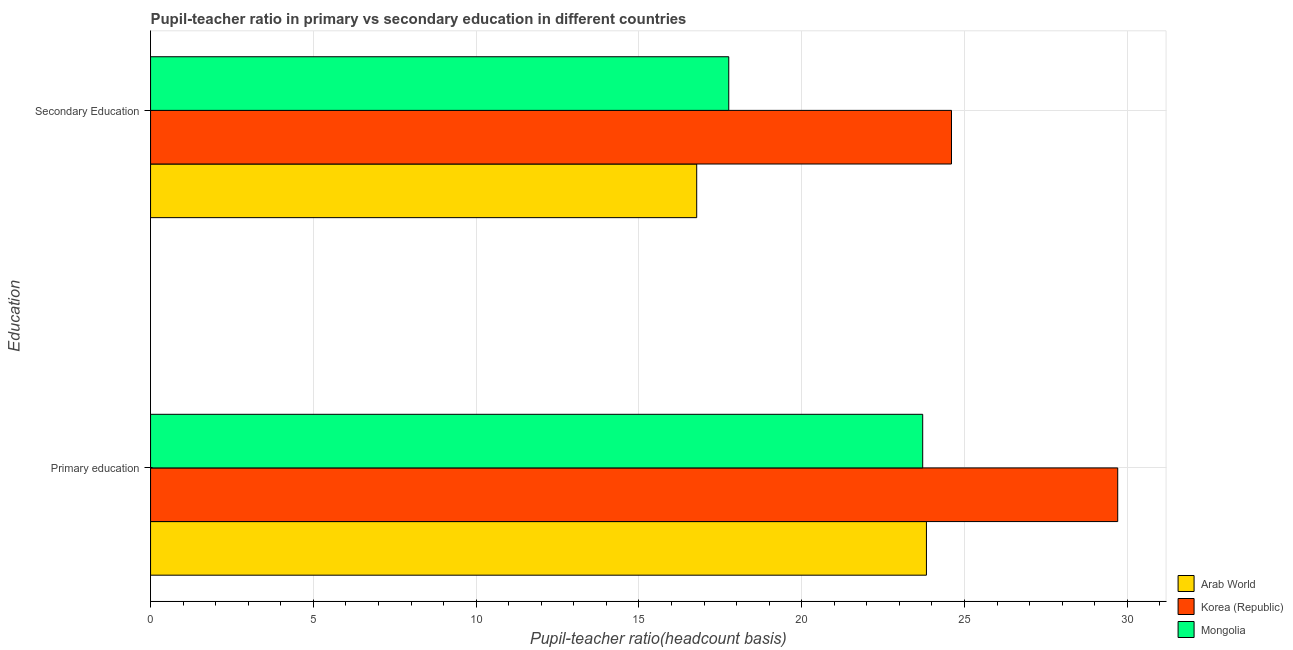How many groups of bars are there?
Provide a short and direct response. 2. Are the number of bars per tick equal to the number of legend labels?
Offer a terse response. Yes. Are the number of bars on each tick of the Y-axis equal?
Offer a terse response. Yes. How many bars are there on the 2nd tick from the top?
Give a very brief answer. 3. How many bars are there on the 2nd tick from the bottom?
Offer a very short reply. 3. What is the label of the 1st group of bars from the top?
Offer a very short reply. Secondary Education. What is the pupil teacher ratio on secondary education in Mongolia?
Your answer should be compact. 17.76. Across all countries, what is the maximum pupil-teacher ratio in primary education?
Offer a terse response. 29.71. Across all countries, what is the minimum pupil teacher ratio on secondary education?
Your answer should be compact. 16.77. In which country was the pupil-teacher ratio in primary education maximum?
Your response must be concise. Korea (Republic). In which country was the pupil-teacher ratio in primary education minimum?
Keep it short and to the point. Mongolia. What is the total pupil teacher ratio on secondary education in the graph?
Your response must be concise. 59.13. What is the difference between the pupil-teacher ratio in primary education in Korea (Republic) and that in Arab World?
Offer a terse response. 5.87. What is the difference between the pupil teacher ratio on secondary education in Arab World and the pupil-teacher ratio in primary education in Mongolia?
Keep it short and to the point. -6.94. What is the average pupil teacher ratio on secondary education per country?
Offer a terse response. 19.71. What is the difference between the pupil teacher ratio on secondary education and pupil-teacher ratio in primary education in Mongolia?
Give a very brief answer. -5.96. In how many countries, is the pupil-teacher ratio in primary education greater than 10 ?
Your response must be concise. 3. What is the ratio of the pupil-teacher ratio in primary education in Arab World to that in Mongolia?
Your answer should be compact. 1. What does the 1st bar from the top in Primary education represents?
Offer a terse response. Mongolia. What does the 1st bar from the bottom in Secondary Education represents?
Offer a terse response. Arab World. How many countries are there in the graph?
Make the answer very short. 3. What is the difference between two consecutive major ticks on the X-axis?
Make the answer very short. 5. Does the graph contain any zero values?
Your response must be concise. No. Where does the legend appear in the graph?
Your answer should be very brief. Bottom right. What is the title of the graph?
Give a very brief answer. Pupil-teacher ratio in primary vs secondary education in different countries. Does "Canada" appear as one of the legend labels in the graph?
Your answer should be compact. No. What is the label or title of the X-axis?
Give a very brief answer. Pupil-teacher ratio(headcount basis). What is the label or title of the Y-axis?
Keep it short and to the point. Education. What is the Pupil-teacher ratio(headcount basis) in Arab World in Primary education?
Ensure brevity in your answer.  23.83. What is the Pupil-teacher ratio(headcount basis) in Korea (Republic) in Primary education?
Offer a very short reply. 29.71. What is the Pupil-teacher ratio(headcount basis) in Mongolia in Primary education?
Offer a terse response. 23.72. What is the Pupil-teacher ratio(headcount basis) of Arab World in Secondary Education?
Offer a very short reply. 16.77. What is the Pupil-teacher ratio(headcount basis) of Korea (Republic) in Secondary Education?
Give a very brief answer. 24.6. What is the Pupil-teacher ratio(headcount basis) of Mongolia in Secondary Education?
Give a very brief answer. 17.76. Across all Education, what is the maximum Pupil-teacher ratio(headcount basis) in Arab World?
Your answer should be very brief. 23.83. Across all Education, what is the maximum Pupil-teacher ratio(headcount basis) in Korea (Republic)?
Ensure brevity in your answer.  29.71. Across all Education, what is the maximum Pupil-teacher ratio(headcount basis) in Mongolia?
Offer a terse response. 23.72. Across all Education, what is the minimum Pupil-teacher ratio(headcount basis) in Arab World?
Ensure brevity in your answer.  16.77. Across all Education, what is the minimum Pupil-teacher ratio(headcount basis) of Korea (Republic)?
Provide a short and direct response. 24.6. Across all Education, what is the minimum Pupil-teacher ratio(headcount basis) in Mongolia?
Keep it short and to the point. 17.76. What is the total Pupil-teacher ratio(headcount basis) in Arab World in the graph?
Offer a very short reply. 40.6. What is the total Pupil-teacher ratio(headcount basis) of Korea (Republic) in the graph?
Provide a short and direct response. 54.31. What is the total Pupil-teacher ratio(headcount basis) in Mongolia in the graph?
Your response must be concise. 41.47. What is the difference between the Pupil-teacher ratio(headcount basis) in Arab World in Primary education and that in Secondary Education?
Provide a short and direct response. 7.06. What is the difference between the Pupil-teacher ratio(headcount basis) in Korea (Republic) in Primary education and that in Secondary Education?
Provide a short and direct response. 5.11. What is the difference between the Pupil-teacher ratio(headcount basis) of Mongolia in Primary education and that in Secondary Education?
Your answer should be compact. 5.96. What is the difference between the Pupil-teacher ratio(headcount basis) in Arab World in Primary education and the Pupil-teacher ratio(headcount basis) in Korea (Republic) in Secondary Education?
Give a very brief answer. -0.77. What is the difference between the Pupil-teacher ratio(headcount basis) in Arab World in Primary education and the Pupil-teacher ratio(headcount basis) in Mongolia in Secondary Education?
Make the answer very short. 6.07. What is the difference between the Pupil-teacher ratio(headcount basis) in Korea (Republic) in Primary education and the Pupil-teacher ratio(headcount basis) in Mongolia in Secondary Education?
Offer a very short reply. 11.95. What is the average Pupil-teacher ratio(headcount basis) in Arab World per Education?
Provide a short and direct response. 20.3. What is the average Pupil-teacher ratio(headcount basis) in Korea (Republic) per Education?
Your response must be concise. 27.15. What is the average Pupil-teacher ratio(headcount basis) of Mongolia per Education?
Your answer should be very brief. 20.74. What is the difference between the Pupil-teacher ratio(headcount basis) in Arab World and Pupil-teacher ratio(headcount basis) in Korea (Republic) in Primary education?
Give a very brief answer. -5.87. What is the difference between the Pupil-teacher ratio(headcount basis) in Arab World and Pupil-teacher ratio(headcount basis) in Mongolia in Primary education?
Your response must be concise. 0.11. What is the difference between the Pupil-teacher ratio(headcount basis) in Korea (Republic) and Pupil-teacher ratio(headcount basis) in Mongolia in Primary education?
Keep it short and to the point. 5.99. What is the difference between the Pupil-teacher ratio(headcount basis) in Arab World and Pupil-teacher ratio(headcount basis) in Korea (Republic) in Secondary Education?
Your answer should be compact. -7.83. What is the difference between the Pupil-teacher ratio(headcount basis) of Arab World and Pupil-teacher ratio(headcount basis) of Mongolia in Secondary Education?
Give a very brief answer. -0.98. What is the difference between the Pupil-teacher ratio(headcount basis) of Korea (Republic) and Pupil-teacher ratio(headcount basis) of Mongolia in Secondary Education?
Your answer should be very brief. 6.84. What is the ratio of the Pupil-teacher ratio(headcount basis) of Arab World in Primary education to that in Secondary Education?
Your answer should be compact. 1.42. What is the ratio of the Pupil-teacher ratio(headcount basis) in Korea (Republic) in Primary education to that in Secondary Education?
Your response must be concise. 1.21. What is the ratio of the Pupil-teacher ratio(headcount basis) in Mongolia in Primary education to that in Secondary Education?
Provide a short and direct response. 1.34. What is the difference between the highest and the second highest Pupil-teacher ratio(headcount basis) of Arab World?
Offer a very short reply. 7.06. What is the difference between the highest and the second highest Pupil-teacher ratio(headcount basis) in Korea (Republic)?
Give a very brief answer. 5.11. What is the difference between the highest and the second highest Pupil-teacher ratio(headcount basis) in Mongolia?
Give a very brief answer. 5.96. What is the difference between the highest and the lowest Pupil-teacher ratio(headcount basis) of Arab World?
Your answer should be compact. 7.06. What is the difference between the highest and the lowest Pupil-teacher ratio(headcount basis) in Korea (Republic)?
Your answer should be compact. 5.11. What is the difference between the highest and the lowest Pupil-teacher ratio(headcount basis) in Mongolia?
Provide a succinct answer. 5.96. 